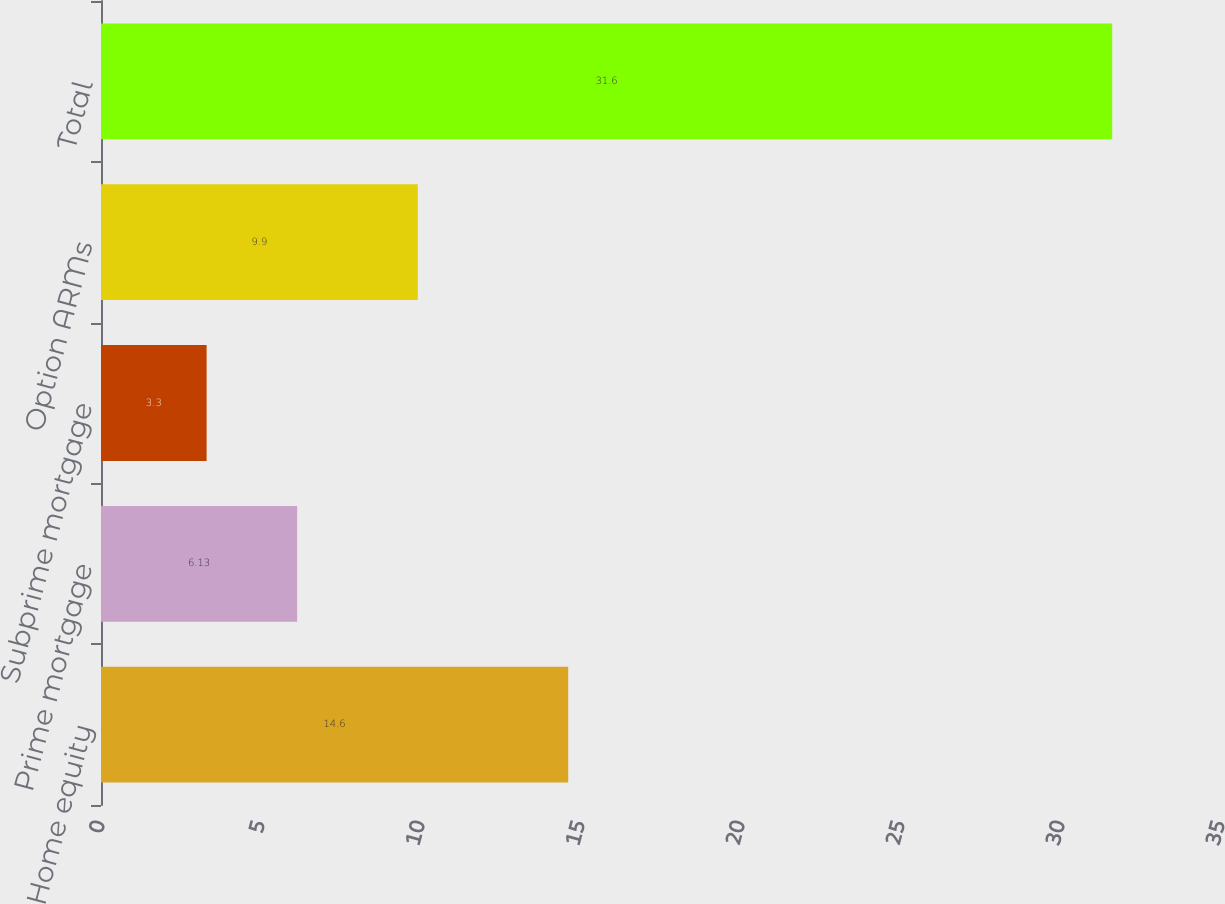Convert chart to OTSL. <chart><loc_0><loc_0><loc_500><loc_500><bar_chart><fcel>Home equity<fcel>Prime mortgage<fcel>Subprime mortgage<fcel>Option ARMs<fcel>Total<nl><fcel>14.6<fcel>6.13<fcel>3.3<fcel>9.9<fcel>31.6<nl></chart> 